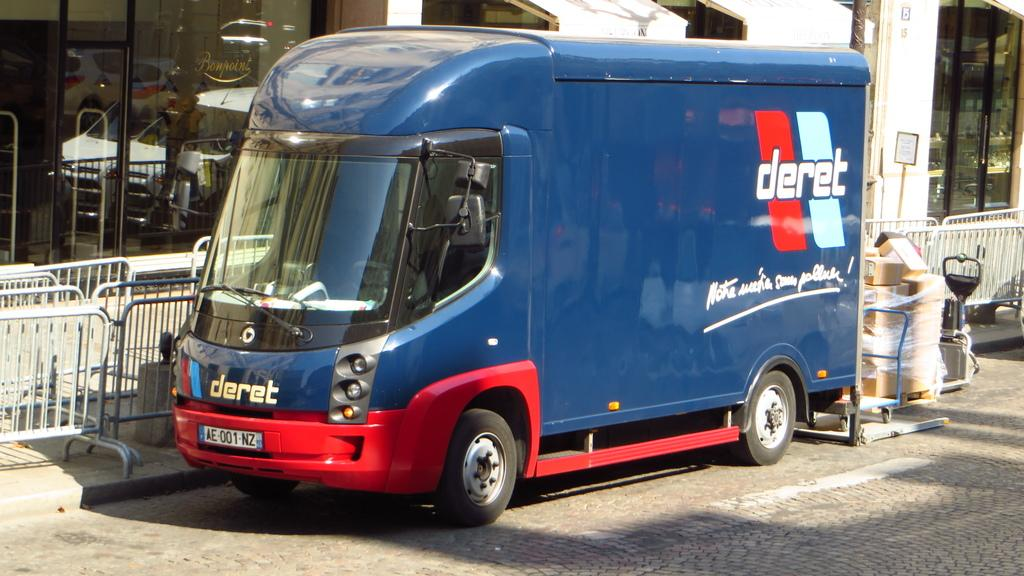What is the main subject in the foreground of the image? There is a truck in the foreground of the image. Where is the truck located? The truck is on the road. What else can be seen in the foreground of the image? There are carton boxes in the foreground. What can be seen in the background of the image? There is a fence, buildings, and a board in the background. What time of day was the image taken? The image was taken during the day. What type of chair is being discussed in the image? There is no chair or discussion present in the image. How many bricks are visible in the image? There are no bricks visible in the image. 